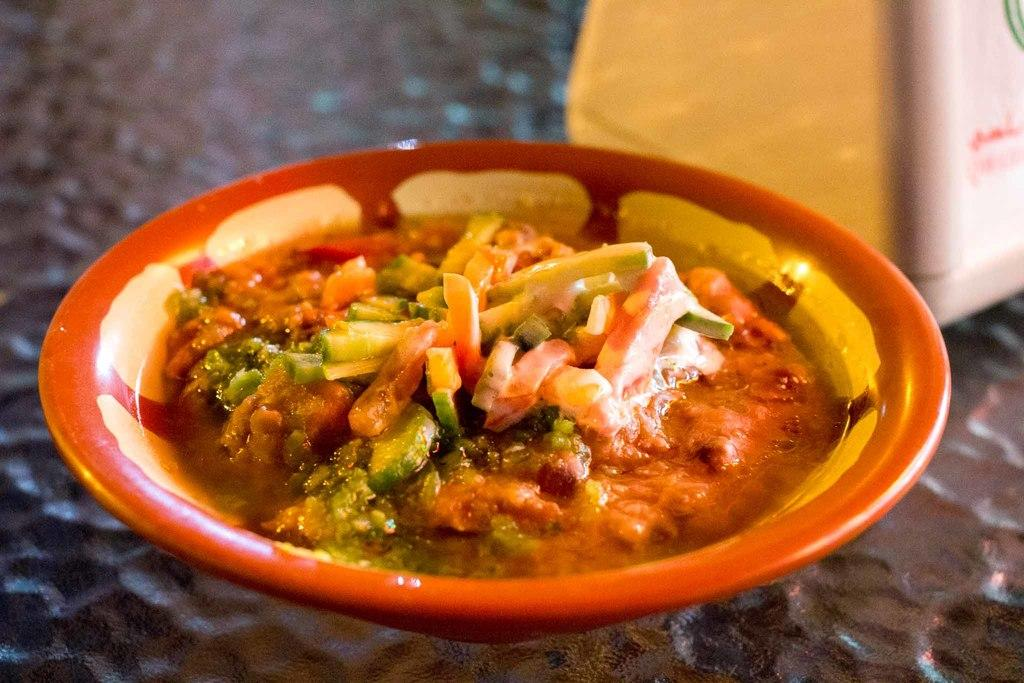What is present in the image that can hold food? There is a bowl in the image that can hold food. What type of food is in the bowl? The facts do not specify the type of food in the bowl. What can be seen on the right side of the image? There is an unspecified object on the right side of the image. How would you describe the background of the image? The background of the image is blurry. Are the sisters in the image feeding the monkey poisoned food? There are no sisters, monkeys, or poison mentioned in the image. 